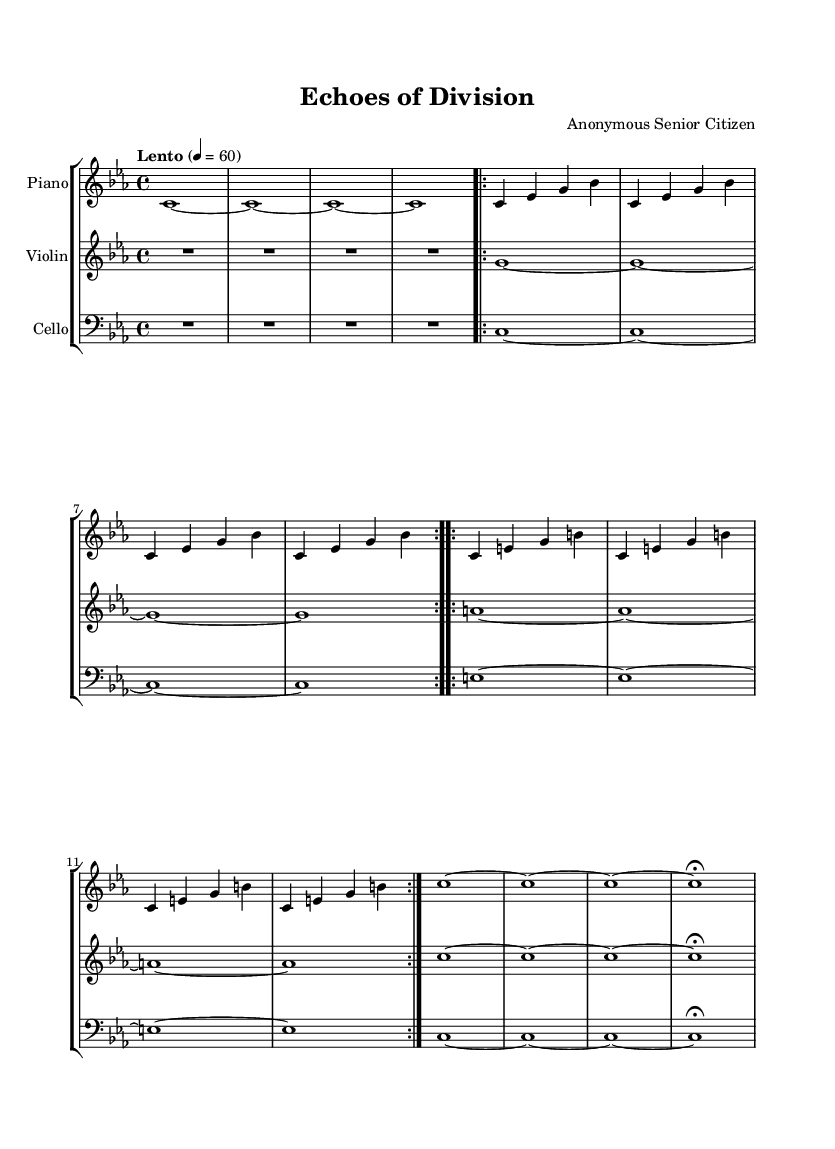What is the key signature of this music? The key signature of the piece is C minor, which is indicated by the key signature that contains three flats.
Answer: C minor What is the time signature of this music? The time signature of the piece is 4/4, meaning there are four beats in each measure and a quarter note gets one beat.
Answer: 4/4 What is the tempo marking for this music? The tempo marking is "Lento," which instructs the musicians to play slowly, at a speed of 60 beats per minute.
Answer: Lento How many measures are in the piano part? To determine the number of measures in the piano part, we count the distinct measures from the beginning to the fermata at the end; there are a total of 10 measures.
Answer: 10 Which instruments are featured in this composition? The composition features three instruments: piano, violin, and cello, as indicated by the staff groupings and instrument names.
Answer: Piano, violin, cello How does the violin part differ from the cello part in terms of note density? The violin part consists of more sustained notes with fewer rhythmic changes compared to the cello part, which also has sustained notes but includes different pitches alongside the violin's sustained phrases.
Answer: More sustained notes 